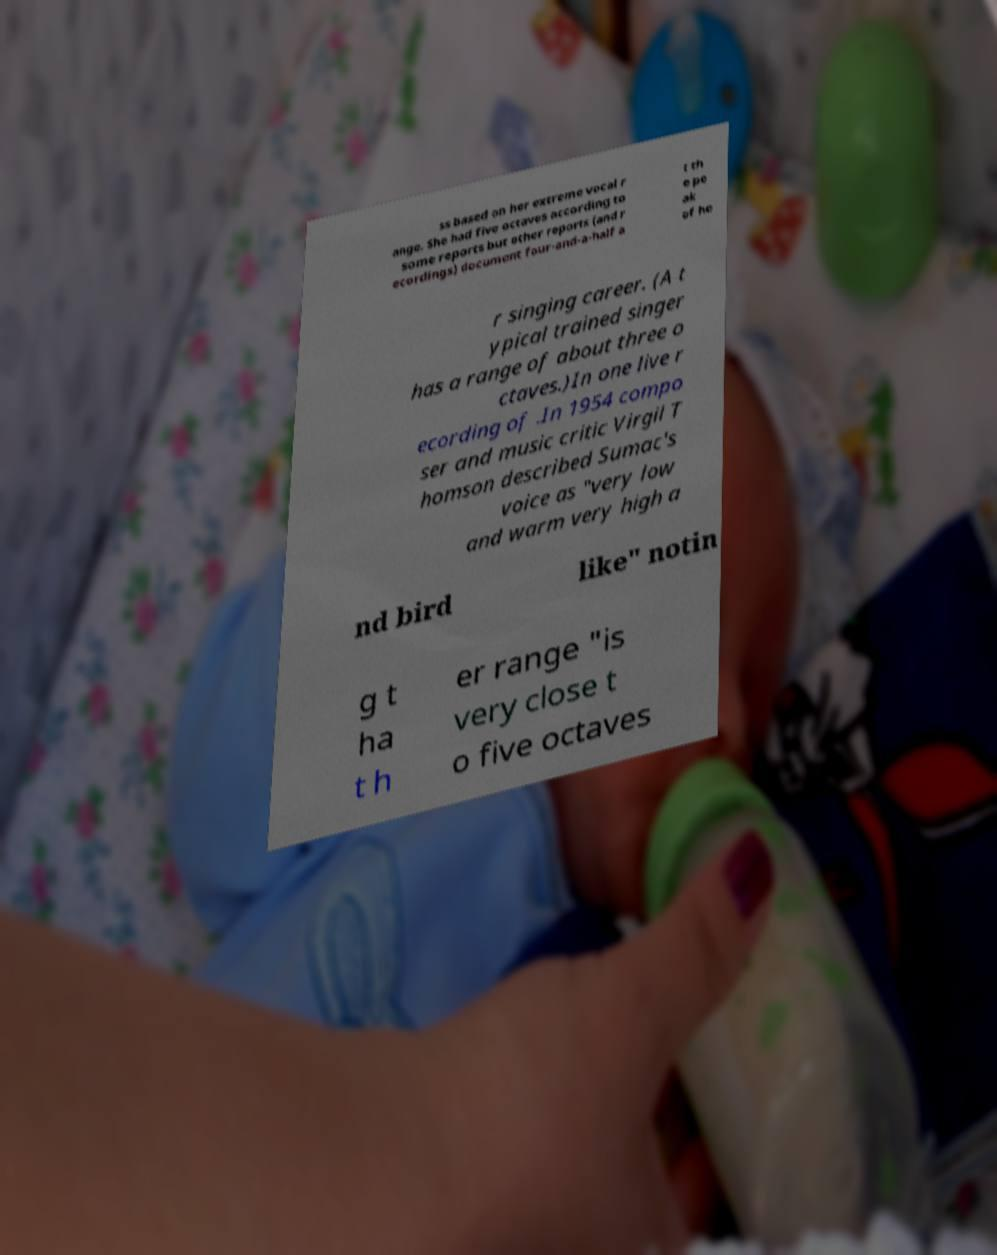Please identify and transcribe the text found in this image. ss based on her extreme vocal r ange. She had five octaves according to some reports but other reports (and r ecordings) document four-and-a-half a t th e pe ak of he r singing career. (A t ypical trained singer has a range of about three o ctaves.)In one live r ecording of .In 1954 compo ser and music critic Virgil T homson described Sumac's voice as "very low and warm very high a nd bird like" notin g t ha t h er range "is very close t o five octaves 